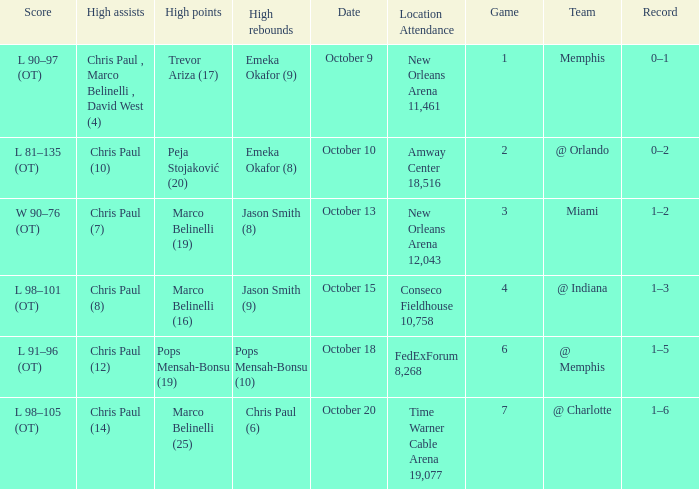What team did the Hornets play in game 4? @ Indiana. 